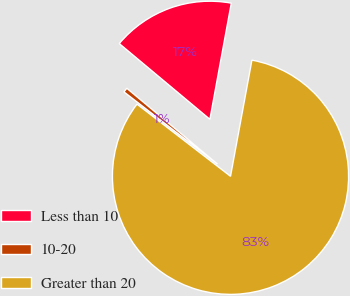Convert chart to OTSL. <chart><loc_0><loc_0><loc_500><loc_500><pie_chart><fcel>Less than 10<fcel>10-20<fcel>Greater than 20<nl><fcel>16.82%<fcel>0.62%<fcel>82.55%<nl></chart> 